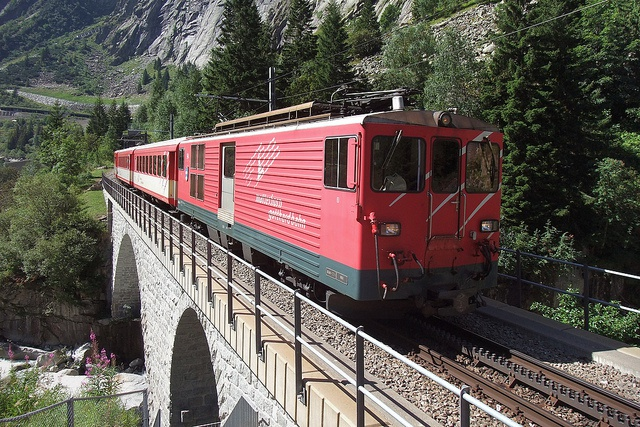Describe the objects in this image and their specific colors. I can see a train in navy, black, maroon, lightpink, and gray tones in this image. 